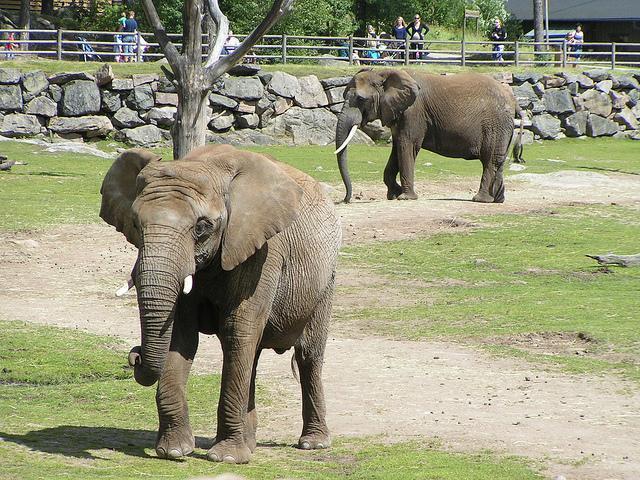At which elevation are the elephants compared to those looking at them?
Pick the correct solution from the four options below to address the question.
Options: Same, lower, changing, higher. Lower. 